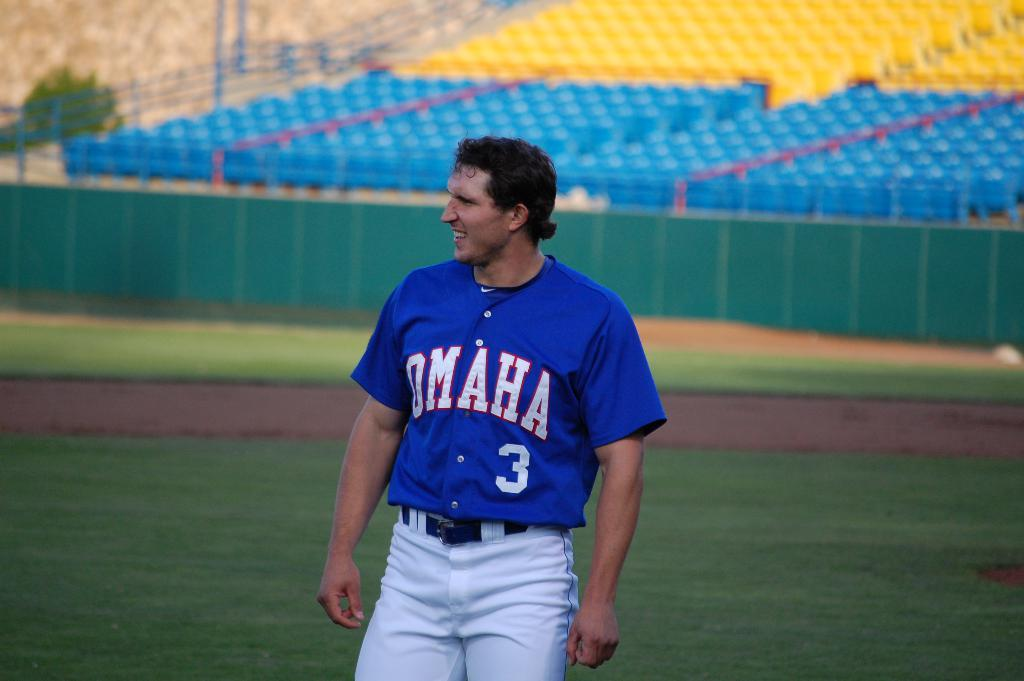<image>
Write a terse but informative summary of the picture. A man wearing a blue Omaha jersey with a number 3 on it. 